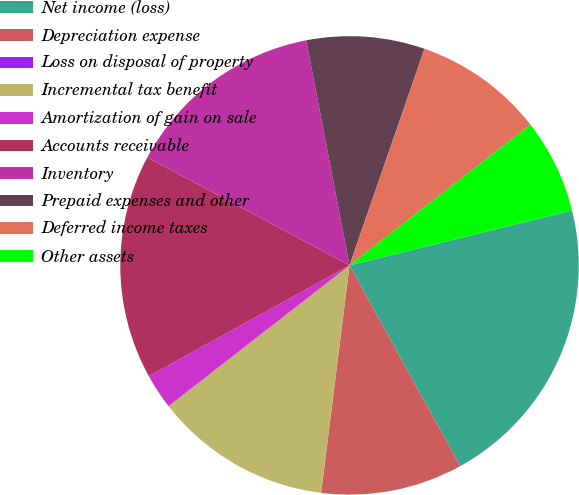Convert chart. <chart><loc_0><loc_0><loc_500><loc_500><pie_chart><fcel>Net income (loss)<fcel>Depreciation expense<fcel>Loss on disposal of property<fcel>Incremental tax benefit<fcel>Amortization of gain on sale<fcel>Accounts receivable<fcel>Inventory<fcel>Prepaid expenses and other<fcel>Deferred income taxes<fcel>Other assets<nl><fcel>20.83%<fcel>10.0%<fcel>0.0%<fcel>12.5%<fcel>2.5%<fcel>15.83%<fcel>14.17%<fcel>8.33%<fcel>9.17%<fcel>6.67%<nl></chart> 